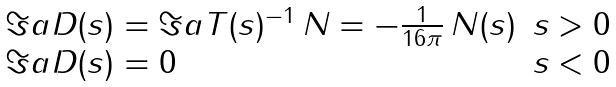<formula> <loc_0><loc_0><loc_500><loc_500>\begin{array} { l l } \Im a D ( s ) = \Im a T ( s ) ^ { - 1 } \, N = - \frac { 1 } { 1 6 \pi } \, N ( s ) & s > 0 \\ \Im a D ( s ) = 0 & s < 0 \end{array}</formula> 